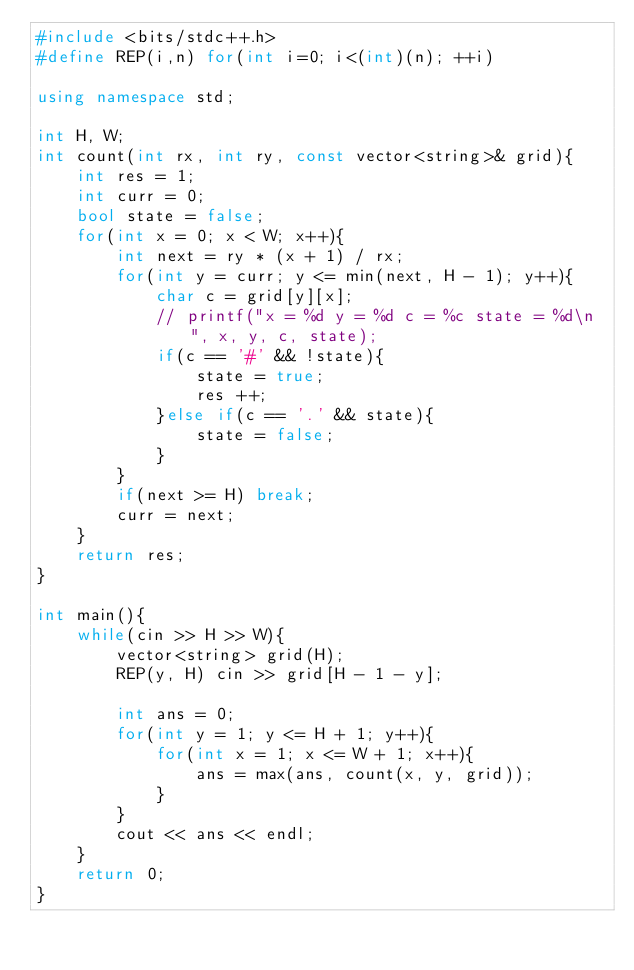<code> <loc_0><loc_0><loc_500><loc_500><_C++_>#include <bits/stdc++.h>
#define REP(i,n) for(int i=0; i<(int)(n); ++i)

using namespace std;

int H, W;
int count(int rx, int ry, const vector<string>& grid){
    int res = 1;
    int curr = 0;
    bool state = false;
    for(int x = 0; x < W; x++){
        int next = ry * (x + 1) / rx;
        for(int y = curr; y <= min(next, H - 1); y++){
            char c = grid[y][x];
            // printf("x = %d y = %d c = %c state = %d\n", x, y, c, state);
            if(c == '#' && !state){
                state = true;
                res ++;
            }else if(c == '.' && state){
                state = false;
            }
        }
        if(next >= H) break;
        curr = next;
    }
    return res;
}

int main(){
    while(cin >> H >> W){
        vector<string> grid(H);
        REP(y, H) cin >> grid[H - 1 - y];

        int ans = 0;
        for(int y = 1; y <= H + 1; y++){
            for(int x = 1; x <= W + 1; x++){
                ans = max(ans, count(x, y, grid));
            }
        }
        cout << ans << endl;
    }
    return 0;
}</code> 